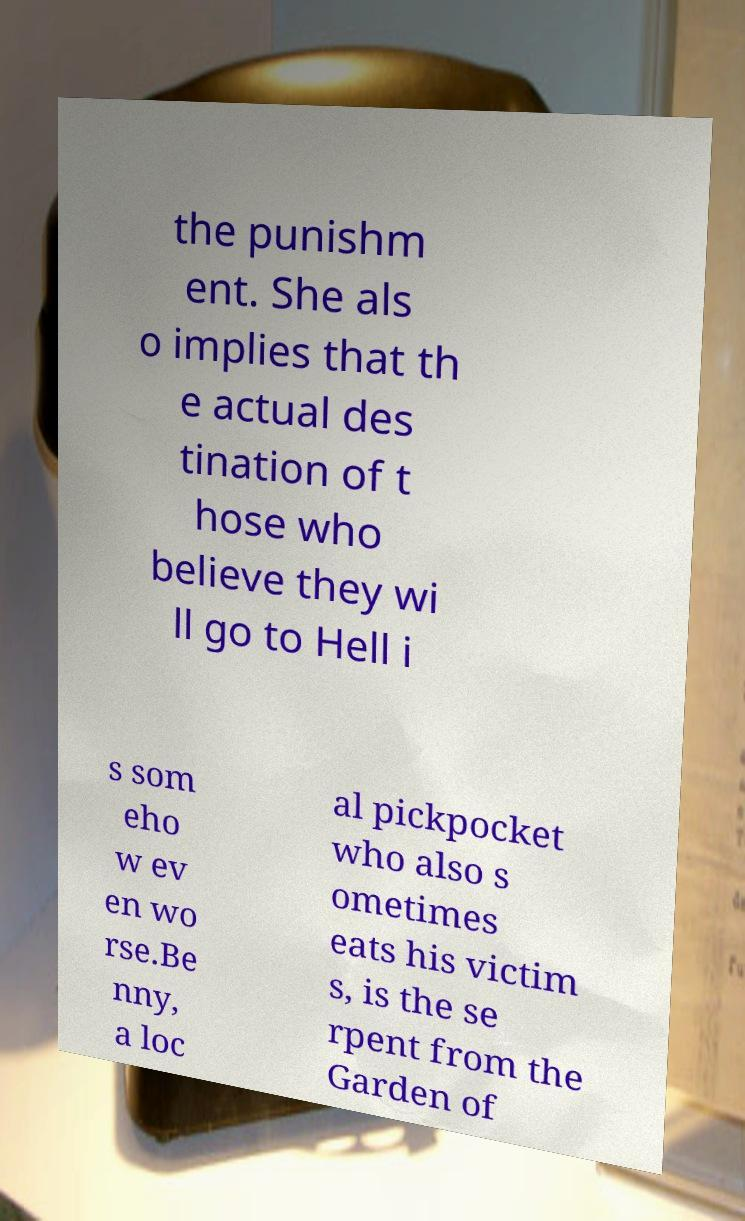Can you read and provide the text displayed in the image?This photo seems to have some interesting text. Can you extract and type it out for me? the punishm ent. She als o implies that th e actual des tination of t hose who believe they wi ll go to Hell i s som eho w ev en wo rse.Be nny, a loc al pickpocket who also s ometimes eats his victim s, is the se rpent from the Garden of 